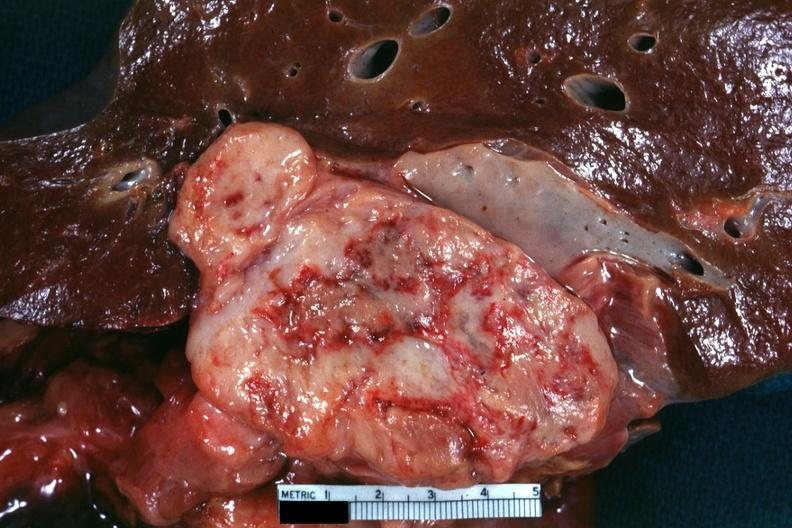what shows cut surface with fish flesh appearance and extensive necrosis very good for illustrating appearance of a sarcoma?
Answer the question using a single word or phrase. This section showing liver tumor mass in hilar area tumor 